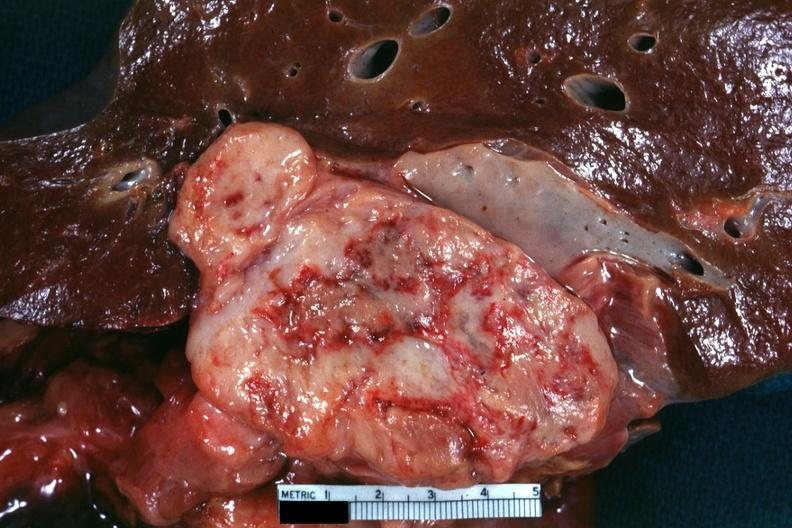what shows cut surface with fish flesh appearance and extensive necrosis very good for illustrating appearance of a sarcoma?
Answer the question using a single word or phrase. This section showing liver tumor mass in hilar area tumor 